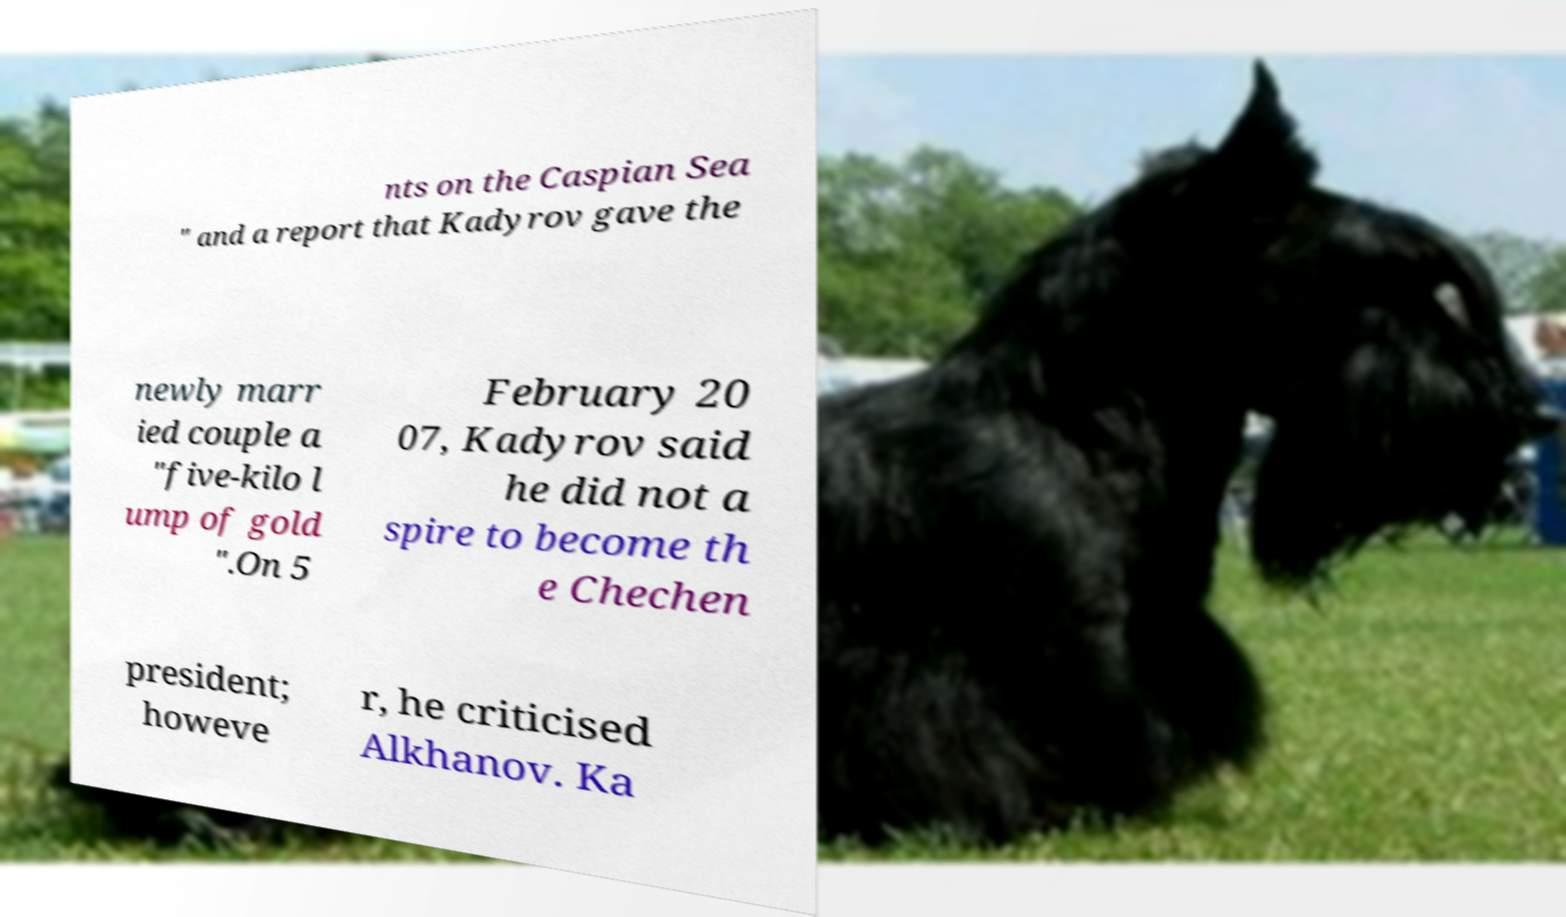Please identify and transcribe the text found in this image. nts on the Caspian Sea " and a report that Kadyrov gave the newly marr ied couple a "five-kilo l ump of gold ".On 5 February 20 07, Kadyrov said he did not a spire to become th e Chechen president; howeve r, he criticised Alkhanov. Ka 